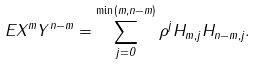<formula> <loc_0><loc_0><loc_500><loc_500>E X ^ { m } Y ^ { n - m } = \sum _ { j = 0 } ^ { \min ( m , n - m ) } \rho ^ { j } H _ { m , j } H _ { n - m , j } .</formula> 